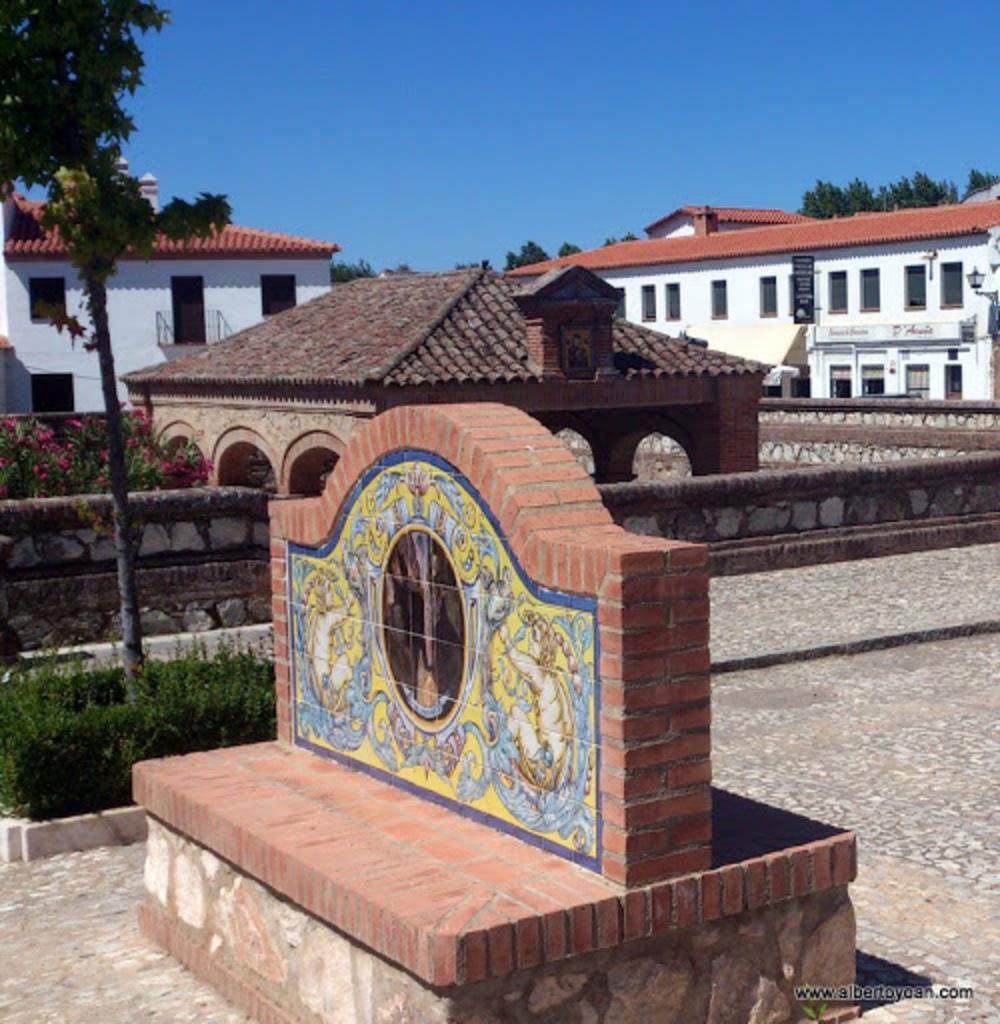How would you summarize this image in a sentence or two? In the center of the picture there are buildings, trees, plants and flowers. In the foreground there is a tree and there are plants and tombstone. Sky is clear and it is sunny. 